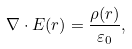<formula> <loc_0><loc_0><loc_500><loc_500>\nabla \cdot E ( r ) = { \frac { \rho ( r ) } { \varepsilon _ { 0 } } } ,</formula> 